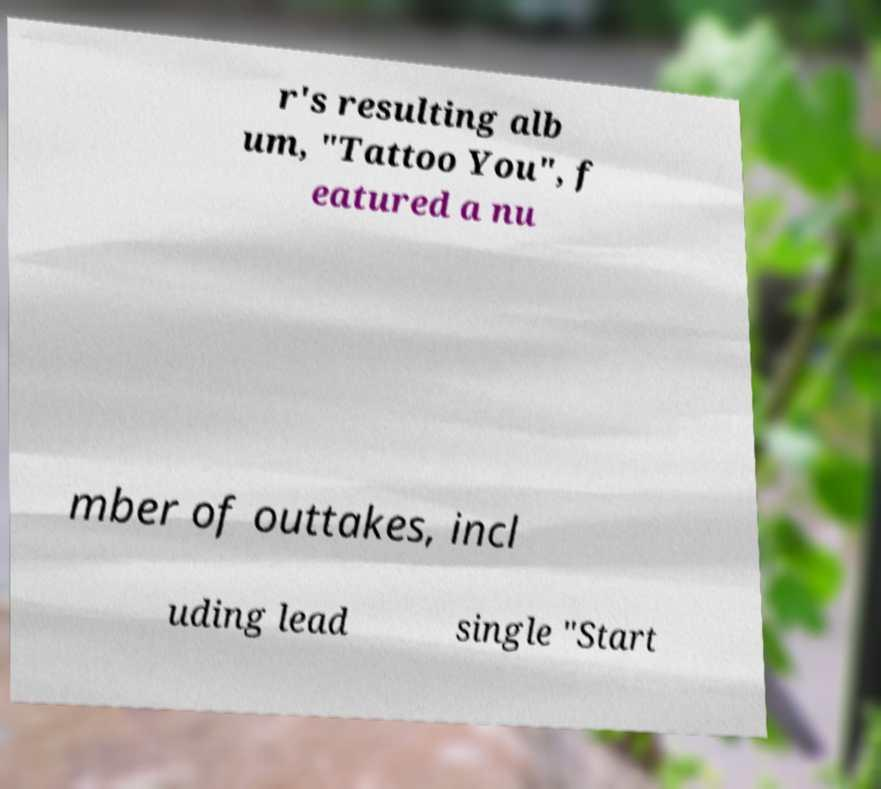Could you extract and type out the text from this image? r's resulting alb um, "Tattoo You", f eatured a nu mber of outtakes, incl uding lead single "Start 